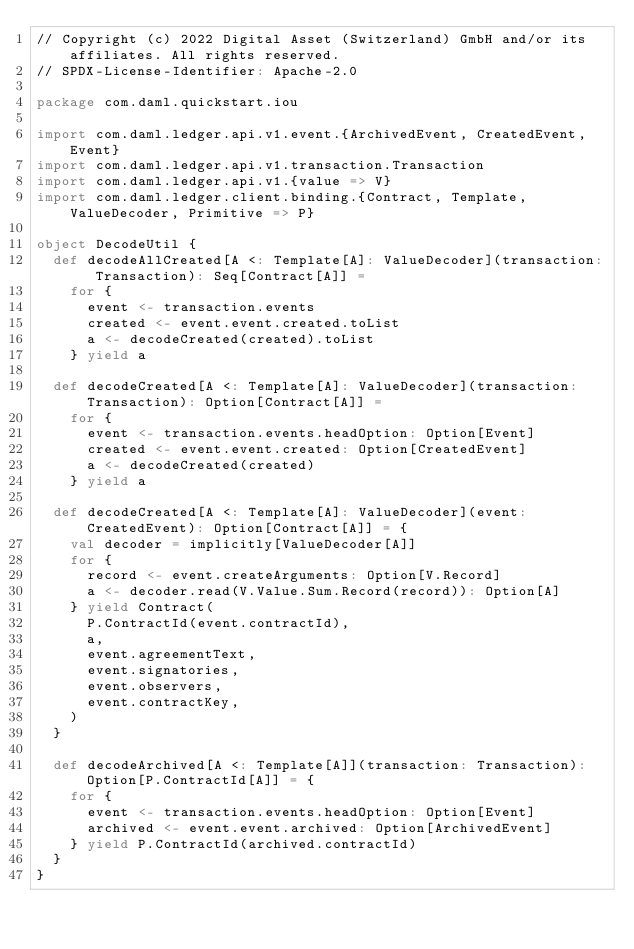Convert code to text. <code><loc_0><loc_0><loc_500><loc_500><_Scala_>// Copyright (c) 2022 Digital Asset (Switzerland) GmbH and/or its affiliates. All rights reserved.
// SPDX-License-Identifier: Apache-2.0

package com.daml.quickstart.iou

import com.daml.ledger.api.v1.event.{ArchivedEvent, CreatedEvent, Event}
import com.daml.ledger.api.v1.transaction.Transaction
import com.daml.ledger.api.v1.{value => V}
import com.daml.ledger.client.binding.{Contract, Template, ValueDecoder, Primitive => P}

object DecodeUtil {
  def decodeAllCreated[A <: Template[A]: ValueDecoder](transaction: Transaction): Seq[Contract[A]] =
    for {
      event <- transaction.events
      created <- event.event.created.toList
      a <- decodeCreated(created).toList
    } yield a

  def decodeCreated[A <: Template[A]: ValueDecoder](transaction: Transaction): Option[Contract[A]] =
    for {
      event <- transaction.events.headOption: Option[Event]
      created <- event.event.created: Option[CreatedEvent]
      a <- decodeCreated(created)
    } yield a

  def decodeCreated[A <: Template[A]: ValueDecoder](event: CreatedEvent): Option[Contract[A]] = {
    val decoder = implicitly[ValueDecoder[A]]
    for {
      record <- event.createArguments: Option[V.Record]
      a <- decoder.read(V.Value.Sum.Record(record)): Option[A]
    } yield Contract(
      P.ContractId(event.contractId),
      a,
      event.agreementText,
      event.signatories,
      event.observers,
      event.contractKey,
    )
  }

  def decodeArchived[A <: Template[A]](transaction: Transaction): Option[P.ContractId[A]] = {
    for {
      event <- transaction.events.headOption: Option[Event]
      archived <- event.event.archived: Option[ArchivedEvent]
    } yield P.ContractId(archived.contractId)
  }
}
</code> 